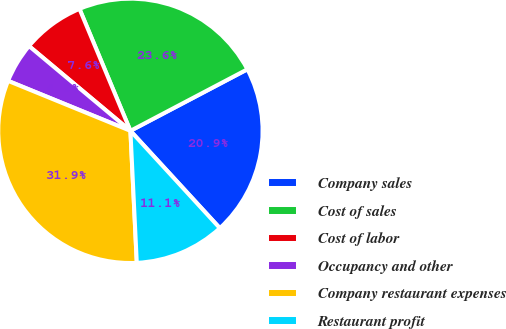<chart> <loc_0><loc_0><loc_500><loc_500><pie_chart><fcel>Company sales<fcel>Cost of sales<fcel>Cost of labor<fcel>Occupancy and other<fcel>Company restaurant expenses<fcel>Restaurant profit<nl><fcel>20.88%<fcel>23.59%<fcel>7.62%<fcel>4.91%<fcel>31.94%<fcel>11.06%<nl></chart> 